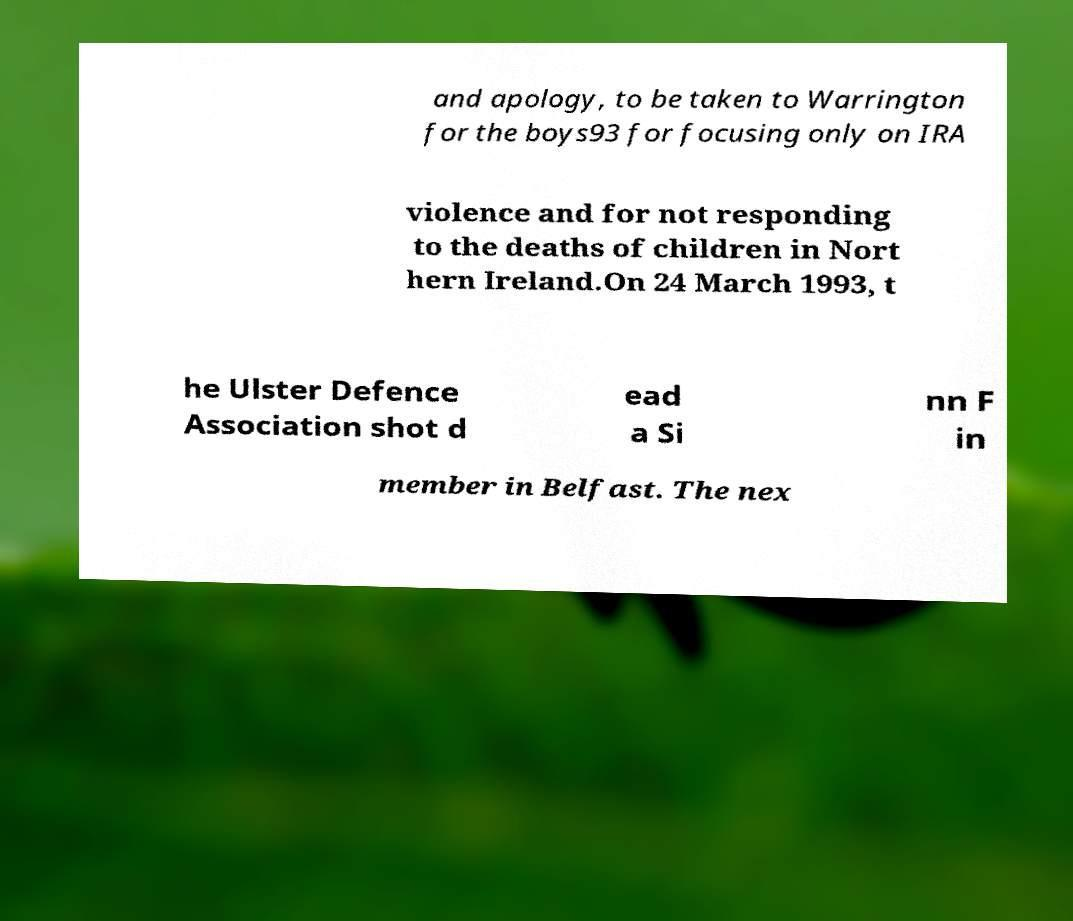For documentation purposes, I need the text within this image transcribed. Could you provide that? and apology, to be taken to Warrington for the boys93 for focusing only on IRA violence and for not responding to the deaths of children in Nort hern Ireland.On 24 March 1993, t he Ulster Defence Association shot d ead a Si nn F in member in Belfast. The nex 